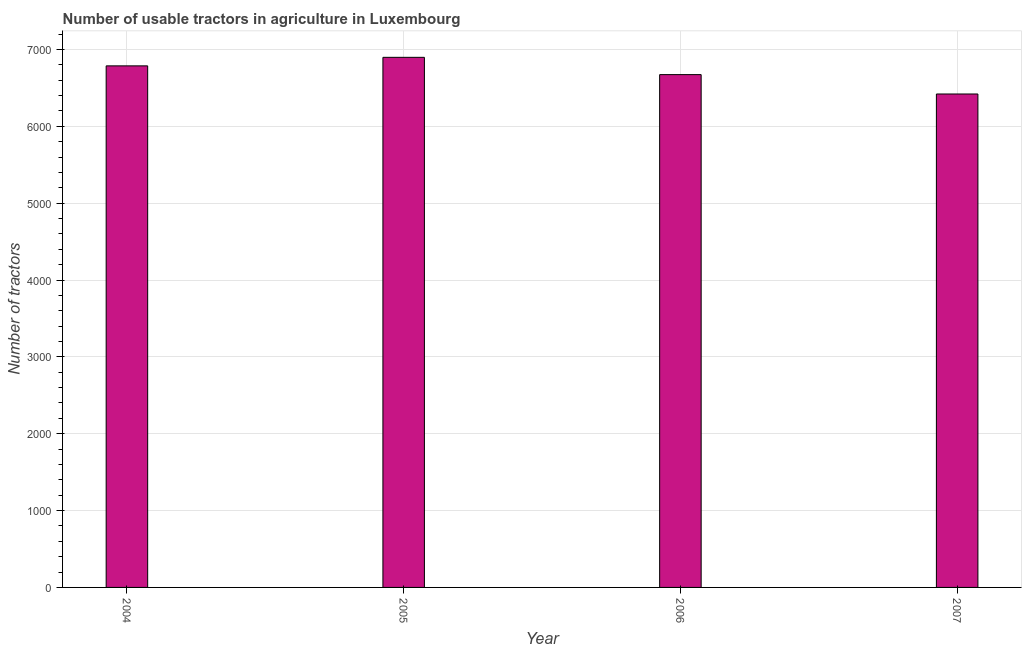Does the graph contain grids?
Your answer should be very brief. Yes. What is the title of the graph?
Offer a very short reply. Number of usable tractors in agriculture in Luxembourg. What is the label or title of the Y-axis?
Your answer should be very brief. Number of tractors. What is the number of tractors in 2006?
Offer a terse response. 6673. Across all years, what is the maximum number of tractors?
Offer a very short reply. 6898. Across all years, what is the minimum number of tractors?
Your answer should be very brief. 6421. In which year was the number of tractors maximum?
Give a very brief answer. 2005. What is the sum of the number of tractors?
Provide a short and direct response. 2.68e+04. What is the difference between the number of tractors in 2005 and 2006?
Offer a terse response. 225. What is the average number of tractors per year?
Your answer should be very brief. 6694. What is the median number of tractors?
Offer a very short reply. 6730. In how many years, is the number of tractors greater than 2800 ?
Give a very brief answer. 4. Do a majority of the years between 2007 and 2005 (inclusive) have number of tractors greater than 6400 ?
Offer a terse response. Yes. What is the ratio of the number of tractors in 2004 to that in 2005?
Make the answer very short. 0.98. Is the difference between the number of tractors in 2004 and 2007 greater than the difference between any two years?
Give a very brief answer. No. What is the difference between the highest and the second highest number of tractors?
Provide a short and direct response. 111. Is the sum of the number of tractors in 2005 and 2006 greater than the maximum number of tractors across all years?
Give a very brief answer. Yes. What is the difference between the highest and the lowest number of tractors?
Your answer should be very brief. 477. In how many years, is the number of tractors greater than the average number of tractors taken over all years?
Your answer should be very brief. 2. How many bars are there?
Provide a short and direct response. 4. Are all the bars in the graph horizontal?
Offer a terse response. No. How many years are there in the graph?
Make the answer very short. 4. What is the difference between two consecutive major ticks on the Y-axis?
Keep it short and to the point. 1000. What is the Number of tractors in 2004?
Provide a short and direct response. 6787. What is the Number of tractors in 2005?
Your response must be concise. 6898. What is the Number of tractors of 2006?
Provide a short and direct response. 6673. What is the Number of tractors of 2007?
Give a very brief answer. 6421. What is the difference between the Number of tractors in 2004 and 2005?
Provide a short and direct response. -111. What is the difference between the Number of tractors in 2004 and 2006?
Your answer should be compact. 114. What is the difference between the Number of tractors in 2004 and 2007?
Provide a succinct answer. 366. What is the difference between the Number of tractors in 2005 and 2006?
Provide a short and direct response. 225. What is the difference between the Number of tractors in 2005 and 2007?
Your answer should be very brief. 477. What is the difference between the Number of tractors in 2006 and 2007?
Give a very brief answer. 252. What is the ratio of the Number of tractors in 2004 to that in 2005?
Provide a short and direct response. 0.98. What is the ratio of the Number of tractors in 2004 to that in 2006?
Provide a short and direct response. 1.02. What is the ratio of the Number of tractors in 2004 to that in 2007?
Give a very brief answer. 1.06. What is the ratio of the Number of tractors in 2005 to that in 2006?
Offer a very short reply. 1.03. What is the ratio of the Number of tractors in 2005 to that in 2007?
Make the answer very short. 1.07. What is the ratio of the Number of tractors in 2006 to that in 2007?
Provide a succinct answer. 1.04. 